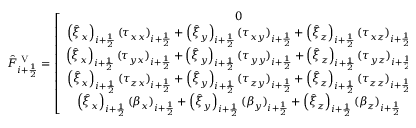<formula> <loc_0><loc_0><loc_500><loc_500>\hat { F } _ { i + \frac { 1 } { 2 } } ^ { V } = \left [ \begin{array} { c } { 0 } \\ { \left ( \hat { \xi } _ { x } \right ) _ { i + \frac { 1 } { 2 } } ( \tau _ { x x } ) _ { i + \frac { 1 } { 2 } } + \left ( \hat { \xi } _ { y } \right ) _ { i + \frac { 1 } { 2 } } ( \tau _ { x y } ) _ { i + \frac { 1 } { 2 } } + \left ( \hat { \xi } _ { z } \right ) _ { i + \frac { 1 } { 2 } } ( \tau _ { x z } ) _ { i + \frac { 1 } { 2 } } } \\ { \left ( \hat { \xi } _ { x } \right ) _ { i + \frac { 1 } { 2 } } ( \tau _ { y x } ) _ { i + \frac { 1 } { 2 } } + \left ( \hat { \xi } _ { y } \right ) _ { i + \frac { 1 } { 2 } } ( \tau _ { y y } ) _ { i + \frac { 1 } { 2 } } + \left ( \hat { \xi } _ { z } \right ) _ { i + \frac { 1 } { 2 } } ( \tau _ { y z } ) _ { i + \frac { 1 } { 2 } } } \\ { \left ( \hat { \xi } _ { x } \right ) _ { i + \frac { 1 } { 2 } } ( \tau _ { z x } ) _ { i + \frac { 1 } { 2 } } + \left ( \hat { \xi } _ { y } \right ) _ { i + \frac { 1 } { 2 } } ( \tau _ { z y } ) _ { i + \frac { 1 } { 2 } } + \left ( \hat { \xi } _ { z } \right ) _ { i + \frac { 1 } { 2 } } ( \tau _ { z z } ) _ { i + \frac { 1 } { 2 } } } \\ { \left ( \hat { \xi } _ { x } \right ) _ { i + \frac { 1 } { 2 } } ( \beta _ { x } ) _ { i + \frac { 1 } { 2 } } + \left ( \hat { \xi } _ { y } \right ) _ { i + \frac { 1 } { 2 } } ( \beta _ { y } ) _ { i + \frac { 1 } { 2 } } + \left ( \hat { \xi } _ { z } \right ) _ { i + \frac { 1 } { 2 } } ( \beta _ { z } ) _ { i + \frac { 1 } { 2 } } } \end{array} \right ]</formula> 